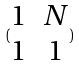<formula> <loc_0><loc_0><loc_500><loc_500>( \begin{matrix} 1 & N \\ 1 & 1 \end{matrix} )</formula> 